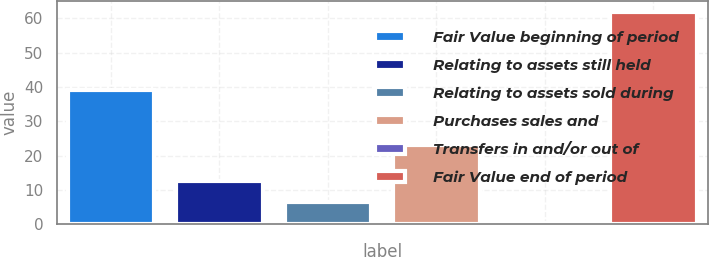Convert chart. <chart><loc_0><loc_0><loc_500><loc_500><bar_chart><fcel>Fair Value beginning of period<fcel>Relating to assets still held<fcel>Relating to assets sold during<fcel>Purchases sales and<fcel>Transfers in and/or out of<fcel>Fair Value end of period<nl><fcel>39<fcel>12.57<fcel>6.39<fcel>23<fcel>0.21<fcel>62<nl></chart> 